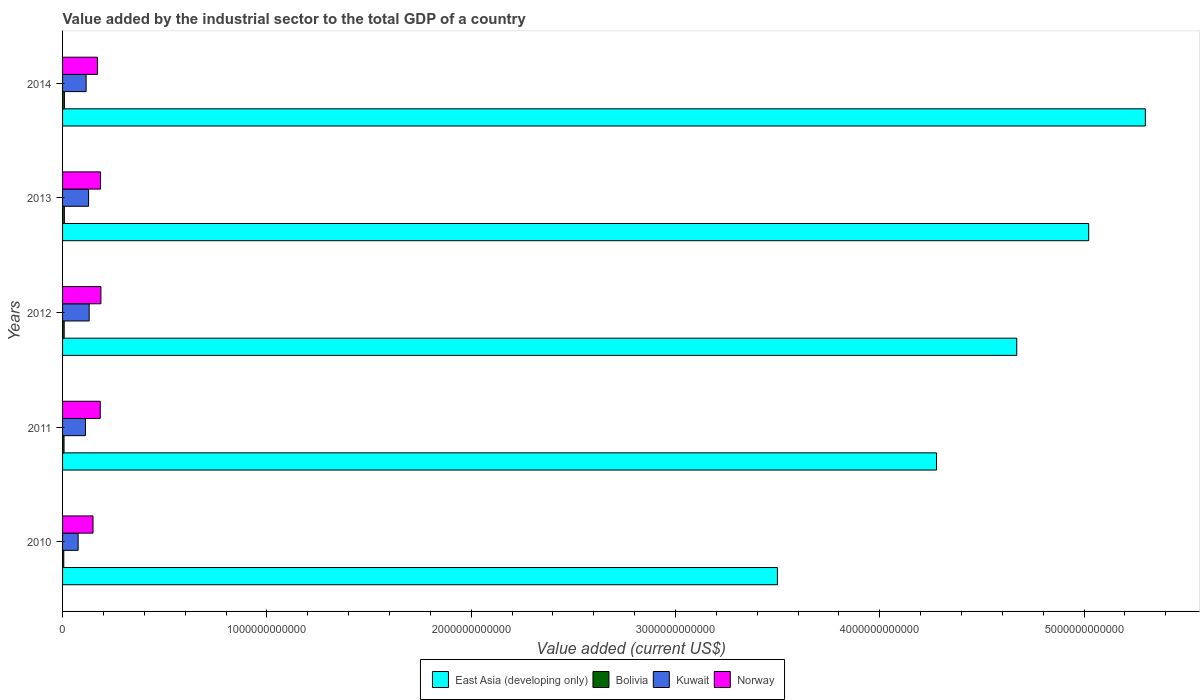How many different coloured bars are there?
Give a very brief answer. 4. How many groups of bars are there?
Make the answer very short. 5. Are the number of bars per tick equal to the number of legend labels?
Your answer should be very brief. Yes. Are the number of bars on each tick of the Y-axis equal?
Provide a short and direct response. Yes. How many bars are there on the 4th tick from the top?
Offer a very short reply. 4. How many bars are there on the 2nd tick from the bottom?
Your answer should be very brief. 4. What is the label of the 3rd group of bars from the top?
Offer a terse response. 2012. In how many cases, is the number of bars for a given year not equal to the number of legend labels?
Your response must be concise. 0. What is the value added by the industrial sector to the total GDP in Kuwait in 2013?
Your response must be concise. 1.27e+11. Across all years, what is the maximum value added by the industrial sector to the total GDP in Kuwait?
Make the answer very short. 1.30e+11. Across all years, what is the minimum value added by the industrial sector to the total GDP in Kuwait?
Your answer should be very brief. 7.63e+1. In which year was the value added by the industrial sector to the total GDP in East Asia (developing only) maximum?
Offer a very short reply. 2014. In which year was the value added by the industrial sector to the total GDP in Kuwait minimum?
Ensure brevity in your answer.  2010. What is the total value added by the industrial sector to the total GDP in Kuwait in the graph?
Provide a succinct answer. 5.61e+11. What is the difference between the value added by the industrial sector to the total GDP in Bolivia in 2011 and that in 2014?
Your answer should be very brief. -1.84e+09. What is the difference between the value added by the industrial sector to the total GDP in Norway in 2010 and the value added by the industrial sector to the total GDP in Bolivia in 2014?
Your response must be concise. 1.40e+11. What is the average value added by the industrial sector to the total GDP in East Asia (developing only) per year?
Make the answer very short. 4.55e+12. In the year 2010, what is the difference between the value added by the industrial sector to the total GDP in Norway and value added by the industrial sector to the total GDP in Bolivia?
Your response must be concise. 1.43e+11. What is the ratio of the value added by the industrial sector to the total GDP in Kuwait in 2011 to that in 2013?
Your answer should be compact. 0.88. Is the value added by the industrial sector to the total GDP in Bolivia in 2012 less than that in 2014?
Give a very brief answer. Yes. What is the difference between the highest and the second highest value added by the industrial sector to the total GDP in Kuwait?
Offer a terse response. 2.92e+09. What is the difference between the highest and the lowest value added by the industrial sector to the total GDP in Bolivia?
Ensure brevity in your answer.  3.19e+09. What does the 1st bar from the top in 2010 represents?
Your response must be concise. Norway. Is it the case that in every year, the sum of the value added by the industrial sector to the total GDP in Norway and value added by the industrial sector to the total GDP in East Asia (developing only) is greater than the value added by the industrial sector to the total GDP in Kuwait?
Keep it short and to the point. Yes. How many bars are there?
Provide a short and direct response. 20. Are all the bars in the graph horizontal?
Provide a succinct answer. Yes. How many years are there in the graph?
Your answer should be very brief. 5. What is the difference between two consecutive major ticks on the X-axis?
Give a very brief answer. 1.00e+12. Are the values on the major ticks of X-axis written in scientific E-notation?
Provide a short and direct response. No. Does the graph contain grids?
Provide a succinct answer. No. Where does the legend appear in the graph?
Offer a terse response. Bottom center. What is the title of the graph?
Your answer should be compact. Value added by the industrial sector to the total GDP of a country. What is the label or title of the X-axis?
Ensure brevity in your answer.  Value added (current US$). What is the Value added (current US$) in East Asia (developing only) in 2010?
Make the answer very short. 3.50e+12. What is the Value added (current US$) of Bolivia in 2010?
Your answer should be compact. 5.92e+09. What is the Value added (current US$) in Kuwait in 2010?
Offer a very short reply. 7.63e+1. What is the Value added (current US$) of Norway in 2010?
Give a very brief answer. 1.49e+11. What is the Value added (current US$) in East Asia (developing only) in 2011?
Provide a succinct answer. 4.28e+12. What is the Value added (current US$) in Bolivia in 2011?
Your answer should be very brief. 7.28e+09. What is the Value added (current US$) in Kuwait in 2011?
Your response must be concise. 1.12e+11. What is the Value added (current US$) of Norway in 2011?
Offer a terse response. 1.84e+11. What is the Value added (current US$) of East Asia (developing only) in 2012?
Offer a terse response. 4.67e+12. What is the Value added (current US$) in Bolivia in 2012?
Give a very brief answer. 7.95e+09. What is the Value added (current US$) of Kuwait in 2012?
Your answer should be compact. 1.30e+11. What is the Value added (current US$) in Norway in 2012?
Ensure brevity in your answer.  1.88e+11. What is the Value added (current US$) of East Asia (developing only) in 2013?
Give a very brief answer. 5.02e+12. What is the Value added (current US$) of Bolivia in 2013?
Your answer should be very brief. 8.74e+09. What is the Value added (current US$) of Kuwait in 2013?
Provide a succinct answer. 1.27e+11. What is the Value added (current US$) in Norway in 2013?
Provide a succinct answer. 1.86e+11. What is the Value added (current US$) of East Asia (developing only) in 2014?
Your answer should be compact. 5.30e+12. What is the Value added (current US$) in Bolivia in 2014?
Your answer should be very brief. 9.12e+09. What is the Value added (current US$) in Kuwait in 2014?
Keep it short and to the point. 1.15e+11. What is the Value added (current US$) of Norway in 2014?
Provide a succinct answer. 1.71e+11. Across all years, what is the maximum Value added (current US$) in East Asia (developing only)?
Your answer should be very brief. 5.30e+12. Across all years, what is the maximum Value added (current US$) of Bolivia?
Keep it short and to the point. 9.12e+09. Across all years, what is the maximum Value added (current US$) of Kuwait?
Provide a short and direct response. 1.30e+11. Across all years, what is the maximum Value added (current US$) of Norway?
Your answer should be compact. 1.88e+11. Across all years, what is the minimum Value added (current US$) in East Asia (developing only)?
Provide a succinct answer. 3.50e+12. Across all years, what is the minimum Value added (current US$) of Bolivia?
Make the answer very short. 5.92e+09. Across all years, what is the minimum Value added (current US$) in Kuwait?
Ensure brevity in your answer.  7.63e+1. Across all years, what is the minimum Value added (current US$) of Norway?
Give a very brief answer. 1.49e+11. What is the total Value added (current US$) in East Asia (developing only) in the graph?
Your response must be concise. 2.28e+13. What is the total Value added (current US$) in Bolivia in the graph?
Offer a terse response. 3.90e+1. What is the total Value added (current US$) of Kuwait in the graph?
Ensure brevity in your answer.  5.61e+11. What is the total Value added (current US$) of Norway in the graph?
Offer a very short reply. 8.78e+11. What is the difference between the Value added (current US$) of East Asia (developing only) in 2010 and that in 2011?
Your response must be concise. -7.79e+11. What is the difference between the Value added (current US$) of Bolivia in 2010 and that in 2011?
Keep it short and to the point. -1.35e+09. What is the difference between the Value added (current US$) in Kuwait in 2010 and that in 2011?
Keep it short and to the point. -3.58e+1. What is the difference between the Value added (current US$) of Norway in 2010 and that in 2011?
Make the answer very short. -3.54e+1. What is the difference between the Value added (current US$) of East Asia (developing only) in 2010 and that in 2012?
Ensure brevity in your answer.  -1.17e+12. What is the difference between the Value added (current US$) of Bolivia in 2010 and that in 2012?
Give a very brief answer. -2.02e+09. What is the difference between the Value added (current US$) in Kuwait in 2010 and that in 2012?
Your answer should be compact. -5.40e+1. What is the difference between the Value added (current US$) in Norway in 2010 and that in 2012?
Your answer should be compact. -3.86e+1. What is the difference between the Value added (current US$) in East Asia (developing only) in 2010 and that in 2013?
Keep it short and to the point. -1.52e+12. What is the difference between the Value added (current US$) of Bolivia in 2010 and that in 2013?
Offer a very short reply. -2.82e+09. What is the difference between the Value added (current US$) in Kuwait in 2010 and that in 2013?
Your answer should be compact. -5.11e+1. What is the difference between the Value added (current US$) of Norway in 2010 and that in 2013?
Provide a short and direct response. -3.69e+1. What is the difference between the Value added (current US$) in East Asia (developing only) in 2010 and that in 2014?
Keep it short and to the point. -1.80e+12. What is the difference between the Value added (current US$) of Bolivia in 2010 and that in 2014?
Give a very brief answer. -3.19e+09. What is the difference between the Value added (current US$) of Kuwait in 2010 and that in 2014?
Your answer should be very brief. -3.91e+1. What is the difference between the Value added (current US$) of Norway in 2010 and that in 2014?
Offer a very short reply. -2.18e+1. What is the difference between the Value added (current US$) in East Asia (developing only) in 2011 and that in 2012?
Offer a terse response. -3.93e+11. What is the difference between the Value added (current US$) of Bolivia in 2011 and that in 2012?
Give a very brief answer. -6.68e+08. What is the difference between the Value added (current US$) in Kuwait in 2011 and that in 2012?
Provide a short and direct response. -1.82e+1. What is the difference between the Value added (current US$) in Norway in 2011 and that in 2012?
Keep it short and to the point. -3.21e+09. What is the difference between the Value added (current US$) in East Asia (developing only) in 2011 and that in 2013?
Provide a short and direct response. -7.45e+11. What is the difference between the Value added (current US$) of Bolivia in 2011 and that in 2013?
Provide a short and direct response. -1.47e+09. What is the difference between the Value added (current US$) of Kuwait in 2011 and that in 2013?
Offer a very short reply. -1.53e+1. What is the difference between the Value added (current US$) of Norway in 2011 and that in 2013?
Provide a short and direct response. -1.47e+09. What is the difference between the Value added (current US$) of East Asia (developing only) in 2011 and that in 2014?
Your response must be concise. -1.02e+12. What is the difference between the Value added (current US$) of Bolivia in 2011 and that in 2014?
Your response must be concise. -1.84e+09. What is the difference between the Value added (current US$) in Kuwait in 2011 and that in 2014?
Ensure brevity in your answer.  -3.30e+09. What is the difference between the Value added (current US$) of Norway in 2011 and that in 2014?
Provide a succinct answer. 1.36e+1. What is the difference between the Value added (current US$) of East Asia (developing only) in 2012 and that in 2013?
Offer a terse response. -3.52e+11. What is the difference between the Value added (current US$) of Bolivia in 2012 and that in 2013?
Offer a very short reply. -7.98e+08. What is the difference between the Value added (current US$) in Kuwait in 2012 and that in 2013?
Provide a short and direct response. 2.92e+09. What is the difference between the Value added (current US$) of Norway in 2012 and that in 2013?
Give a very brief answer. 1.74e+09. What is the difference between the Value added (current US$) in East Asia (developing only) in 2012 and that in 2014?
Your response must be concise. -6.29e+11. What is the difference between the Value added (current US$) in Bolivia in 2012 and that in 2014?
Make the answer very short. -1.17e+09. What is the difference between the Value added (current US$) of Kuwait in 2012 and that in 2014?
Keep it short and to the point. 1.49e+1. What is the difference between the Value added (current US$) in Norway in 2012 and that in 2014?
Ensure brevity in your answer.  1.68e+1. What is the difference between the Value added (current US$) in East Asia (developing only) in 2013 and that in 2014?
Your response must be concise. -2.77e+11. What is the difference between the Value added (current US$) in Bolivia in 2013 and that in 2014?
Keep it short and to the point. -3.72e+08. What is the difference between the Value added (current US$) in Kuwait in 2013 and that in 2014?
Ensure brevity in your answer.  1.20e+1. What is the difference between the Value added (current US$) in Norway in 2013 and that in 2014?
Offer a very short reply. 1.51e+1. What is the difference between the Value added (current US$) of East Asia (developing only) in 2010 and the Value added (current US$) of Bolivia in 2011?
Your response must be concise. 3.49e+12. What is the difference between the Value added (current US$) of East Asia (developing only) in 2010 and the Value added (current US$) of Kuwait in 2011?
Your response must be concise. 3.39e+12. What is the difference between the Value added (current US$) of East Asia (developing only) in 2010 and the Value added (current US$) of Norway in 2011?
Give a very brief answer. 3.31e+12. What is the difference between the Value added (current US$) of Bolivia in 2010 and the Value added (current US$) of Kuwait in 2011?
Give a very brief answer. -1.06e+11. What is the difference between the Value added (current US$) in Bolivia in 2010 and the Value added (current US$) in Norway in 2011?
Offer a very short reply. -1.79e+11. What is the difference between the Value added (current US$) in Kuwait in 2010 and the Value added (current US$) in Norway in 2011?
Keep it short and to the point. -1.08e+11. What is the difference between the Value added (current US$) in East Asia (developing only) in 2010 and the Value added (current US$) in Bolivia in 2012?
Your response must be concise. 3.49e+12. What is the difference between the Value added (current US$) in East Asia (developing only) in 2010 and the Value added (current US$) in Kuwait in 2012?
Your response must be concise. 3.37e+12. What is the difference between the Value added (current US$) of East Asia (developing only) in 2010 and the Value added (current US$) of Norway in 2012?
Make the answer very short. 3.31e+12. What is the difference between the Value added (current US$) of Bolivia in 2010 and the Value added (current US$) of Kuwait in 2012?
Provide a succinct answer. -1.24e+11. What is the difference between the Value added (current US$) in Bolivia in 2010 and the Value added (current US$) in Norway in 2012?
Keep it short and to the point. -1.82e+11. What is the difference between the Value added (current US$) of Kuwait in 2010 and the Value added (current US$) of Norway in 2012?
Your answer should be very brief. -1.11e+11. What is the difference between the Value added (current US$) of East Asia (developing only) in 2010 and the Value added (current US$) of Bolivia in 2013?
Provide a succinct answer. 3.49e+12. What is the difference between the Value added (current US$) of East Asia (developing only) in 2010 and the Value added (current US$) of Kuwait in 2013?
Keep it short and to the point. 3.37e+12. What is the difference between the Value added (current US$) of East Asia (developing only) in 2010 and the Value added (current US$) of Norway in 2013?
Provide a short and direct response. 3.31e+12. What is the difference between the Value added (current US$) in Bolivia in 2010 and the Value added (current US$) in Kuwait in 2013?
Provide a succinct answer. -1.21e+11. What is the difference between the Value added (current US$) of Bolivia in 2010 and the Value added (current US$) of Norway in 2013?
Provide a succinct answer. -1.80e+11. What is the difference between the Value added (current US$) in Kuwait in 2010 and the Value added (current US$) in Norway in 2013?
Your answer should be compact. -1.10e+11. What is the difference between the Value added (current US$) of East Asia (developing only) in 2010 and the Value added (current US$) of Bolivia in 2014?
Provide a succinct answer. 3.49e+12. What is the difference between the Value added (current US$) of East Asia (developing only) in 2010 and the Value added (current US$) of Kuwait in 2014?
Your answer should be very brief. 3.38e+12. What is the difference between the Value added (current US$) of East Asia (developing only) in 2010 and the Value added (current US$) of Norway in 2014?
Offer a very short reply. 3.33e+12. What is the difference between the Value added (current US$) of Bolivia in 2010 and the Value added (current US$) of Kuwait in 2014?
Your answer should be very brief. -1.09e+11. What is the difference between the Value added (current US$) of Bolivia in 2010 and the Value added (current US$) of Norway in 2014?
Provide a short and direct response. -1.65e+11. What is the difference between the Value added (current US$) in Kuwait in 2010 and the Value added (current US$) in Norway in 2014?
Provide a succinct answer. -9.46e+1. What is the difference between the Value added (current US$) in East Asia (developing only) in 2011 and the Value added (current US$) in Bolivia in 2012?
Provide a short and direct response. 4.27e+12. What is the difference between the Value added (current US$) in East Asia (developing only) in 2011 and the Value added (current US$) in Kuwait in 2012?
Your answer should be compact. 4.15e+12. What is the difference between the Value added (current US$) of East Asia (developing only) in 2011 and the Value added (current US$) of Norway in 2012?
Offer a terse response. 4.09e+12. What is the difference between the Value added (current US$) in Bolivia in 2011 and the Value added (current US$) in Kuwait in 2012?
Give a very brief answer. -1.23e+11. What is the difference between the Value added (current US$) of Bolivia in 2011 and the Value added (current US$) of Norway in 2012?
Give a very brief answer. -1.80e+11. What is the difference between the Value added (current US$) in Kuwait in 2011 and the Value added (current US$) in Norway in 2012?
Offer a very short reply. -7.57e+1. What is the difference between the Value added (current US$) of East Asia (developing only) in 2011 and the Value added (current US$) of Bolivia in 2013?
Your answer should be very brief. 4.27e+12. What is the difference between the Value added (current US$) in East Asia (developing only) in 2011 and the Value added (current US$) in Kuwait in 2013?
Ensure brevity in your answer.  4.15e+12. What is the difference between the Value added (current US$) in East Asia (developing only) in 2011 and the Value added (current US$) in Norway in 2013?
Your answer should be compact. 4.09e+12. What is the difference between the Value added (current US$) in Bolivia in 2011 and the Value added (current US$) in Kuwait in 2013?
Offer a terse response. -1.20e+11. What is the difference between the Value added (current US$) in Bolivia in 2011 and the Value added (current US$) in Norway in 2013?
Provide a succinct answer. -1.79e+11. What is the difference between the Value added (current US$) in Kuwait in 2011 and the Value added (current US$) in Norway in 2013?
Offer a terse response. -7.40e+1. What is the difference between the Value added (current US$) of East Asia (developing only) in 2011 and the Value added (current US$) of Bolivia in 2014?
Your answer should be very brief. 4.27e+12. What is the difference between the Value added (current US$) in East Asia (developing only) in 2011 and the Value added (current US$) in Kuwait in 2014?
Offer a very short reply. 4.16e+12. What is the difference between the Value added (current US$) of East Asia (developing only) in 2011 and the Value added (current US$) of Norway in 2014?
Offer a very short reply. 4.11e+12. What is the difference between the Value added (current US$) in Bolivia in 2011 and the Value added (current US$) in Kuwait in 2014?
Your answer should be very brief. -1.08e+11. What is the difference between the Value added (current US$) of Bolivia in 2011 and the Value added (current US$) of Norway in 2014?
Make the answer very short. -1.64e+11. What is the difference between the Value added (current US$) of Kuwait in 2011 and the Value added (current US$) of Norway in 2014?
Ensure brevity in your answer.  -5.89e+1. What is the difference between the Value added (current US$) of East Asia (developing only) in 2012 and the Value added (current US$) of Bolivia in 2013?
Offer a very short reply. 4.66e+12. What is the difference between the Value added (current US$) in East Asia (developing only) in 2012 and the Value added (current US$) in Kuwait in 2013?
Offer a very short reply. 4.54e+12. What is the difference between the Value added (current US$) in East Asia (developing only) in 2012 and the Value added (current US$) in Norway in 2013?
Your response must be concise. 4.48e+12. What is the difference between the Value added (current US$) of Bolivia in 2012 and the Value added (current US$) of Kuwait in 2013?
Make the answer very short. -1.19e+11. What is the difference between the Value added (current US$) of Bolivia in 2012 and the Value added (current US$) of Norway in 2013?
Keep it short and to the point. -1.78e+11. What is the difference between the Value added (current US$) in Kuwait in 2012 and the Value added (current US$) in Norway in 2013?
Make the answer very short. -5.57e+1. What is the difference between the Value added (current US$) in East Asia (developing only) in 2012 and the Value added (current US$) in Bolivia in 2014?
Give a very brief answer. 4.66e+12. What is the difference between the Value added (current US$) in East Asia (developing only) in 2012 and the Value added (current US$) in Kuwait in 2014?
Your answer should be very brief. 4.56e+12. What is the difference between the Value added (current US$) in East Asia (developing only) in 2012 and the Value added (current US$) in Norway in 2014?
Your answer should be very brief. 4.50e+12. What is the difference between the Value added (current US$) in Bolivia in 2012 and the Value added (current US$) in Kuwait in 2014?
Offer a very short reply. -1.07e+11. What is the difference between the Value added (current US$) in Bolivia in 2012 and the Value added (current US$) in Norway in 2014?
Give a very brief answer. -1.63e+11. What is the difference between the Value added (current US$) in Kuwait in 2012 and the Value added (current US$) in Norway in 2014?
Your answer should be compact. -4.06e+1. What is the difference between the Value added (current US$) of East Asia (developing only) in 2013 and the Value added (current US$) of Bolivia in 2014?
Give a very brief answer. 5.01e+12. What is the difference between the Value added (current US$) of East Asia (developing only) in 2013 and the Value added (current US$) of Kuwait in 2014?
Your answer should be compact. 4.91e+12. What is the difference between the Value added (current US$) of East Asia (developing only) in 2013 and the Value added (current US$) of Norway in 2014?
Offer a terse response. 4.85e+12. What is the difference between the Value added (current US$) of Bolivia in 2013 and the Value added (current US$) of Kuwait in 2014?
Offer a very short reply. -1.07e+11. What is the difference between the Value added (current US$) in Bolivia in 2013 and the Value added (current US$) in Norway in 2014?
Your answer should be compact. -1.62e+11. What is the difference between the Value added (current US$) of Kuwait in 2013 and the Value added (current US$) of Norway in 2014?
Your response must be concise. -4.36e+1. What is the average Value added (current US$) of East Asia (developing only) per year?
Your answer should be very brief. 4.55e+12. What is the average Value added (current US$) of Bolivia per year?
Give a very brief answer. 7.80e+09. What is the average Value added (current US$) of Kuwait per year?
Offer a terse response. 1.12e+11. What is the average Value added (current US$) in Norway per year?
Your response must be concise. 1.76e+11. In the year 2010, what is the difference between the Value added (current US$) in East Asia (developing only) and Value added (current US$) in Bolivia?
Keep it short and to the point. 3.49e+12. In the year 2010, what is the difference between the Value added (current US$) of East Asia (developing only) and Value added (current US$) of Kuwait?
Ensure brevity in your answer.  3.42e+12. In the year 2010, what is the difference between the Value added (current US$) in East Asia (developing only) and Value added (current US$) in Norway?
Keep it short and to the point. 3.35e+12. In the year 2010, what is the difference between the Value added (current US$) in Bolivia and Value added (current US$) in Kuwait?
Give a very brief answer. -7.03e+1. In the year 2010, what is the difference between the Value added (current US$) of Bolivia and Value added (current US$) of Norway?
Your response must be concise. -1.43e+11. In the year 2010, what is the difference between the Value added (current US$) of Kuwait and Value added (current US$) of Norway?
Keep it short and to the point. -7.28e+1. In the year 2011, what is the difference between the Value added (current US$) in East Asia (developing only) and Value added (current US$) in Bolivia?
Ensure brevity in your answer.  4.27e+12. In the year 2011, what is the difference between the Value added (current US$) of East Asia (developing only) and Value added (current US$) of Kuwait?
Offer a very short reply. 4.17e+12. In the year 2011, what is the difference between the Value added (current US$) in East Asia (developing only) and Value added (current US$) in Norway?
Your response must be concise. 4.09e+12. In the year 2011, what is the difference between the Value added (current US$) of Bolivia and Value added (current US$) of Kuwait?
Provide a succinct answer. -1.05e+11. In the year 2011, what is the difference between the Value added (current US$) of Bolivia and Value added (current US$) of Norway?
Offer a terse response. -1.77e+11. In the year 2011, what is the difference between the Value added (current US$) of Kuwait and Value added (current US$) of Norway?
Ensure brevity in your answer.  -7.25e+1. In the year 2012, what is the difference between the Value added (current US$) of East Asia (developing only) and Value added (current US$) of Bolivia?
Ensure brevity in your answer.  4.66e+12. In the year 2012, what is the difference between the Value added (current US$) in East Asia (developing only) and Value added (current US$) in Kuwait?
Provide a short and direct response. 4.54e+12. In the year 2012, what is the difference between the Value added (current US$) in East Asia (developing only) and Value added (current US$) in Norway?
Provide a succinct answer. 4.48e+12. In the year 2012, what is the difference between the Value added (current US$) of Bolivia and Value added (current US$) of Kuwait?
Provide a short and direct response. -1.22e+11. In the year 2012, what is the difference between the Value added (current US$) of Bolivia and Value added (current US$) of Norway?
Offer a terse response. -1.80e+11. In the year 2012, what is the difference between the Value added (current US$) of Kuwait and Value added (current US$) of Norway?
Offer a very short reply. -5.75e+1. In the year 2013, what is the difference between the Value added (current US$) in East Asia (developing only) and Value added (current US$) in Bolivia?
Ensure brevity in your answer.  5.01e+12. In the year 2013, what is the difference between the Value added (current US$) in East Asia (developing only) and Value added (current US$) in Kuwait?
Your answer should be very brief. 4.90e+12. In the year 2013, what is the difference between the Value added (current US$) of East Asia (developing only) and Value added (current US$) of Norway?
Offer a terse response. 4.84e+12. In the year 2013, what is the difference between the Value added (current US$) of Bolivia and Value added (current US$) of Kuwait?
Your response must be concise. -1.19e+11. In the year 2013, what is the difference between the Value added (current US$) of Bolivia and Value added (current US$) of Norway?
Your answer should be compact. -1.77e+11. In the year 2013, what is the difference between the Value added (current US$) of Kuwait and Value added (current US$) of Norway?
Offer a very short reply. -5.87e+1. In the year 2014, what is the difference between the Value added (current US$) of East Asia (developing only) and Value added (current US$) of Bolivia?
Your answer should be compact. 5.29e+12. In the year 2014, what is the difference between the Value added (current US$) in East Asia (developing only) and Value added (current US$) in Kuwait?
Ensure brevity in your answer.  5.18e+12. In the year 2014, what is the difference between the Value added (current US$) in East Asia (developing only) and Value added (current US$) in Norway?
Your answer should be compact. 5.13e+12. In the year 2014, what is the difference between the Value added (current US$) of Bolivia and Value added (current US$) of Kuwait?
Provide a short and direct response. -1.06e+11. In the year 2014, what is the difference between the Value added (current US$) of Bolivia and Value added (current US$) of Norway?
Provide a short and direct response. -1.62e+11. In the year 2014, what is the difference between the Value added (current US$) in Kuwait and Value added (current US$) in Norway?
Your response must be concise. -5.56e+1. What is the ratio of the Value added (current US$) in East Asia (developing only) in 2010 to that in 2011?
Your response must be concise. 0.82. What is the ratio of the Value added (current US$) in Bolivia in 2010 to that in 2011?
Your response must be concise. 0.81. What is the ratio of the Value added (current US$) in Kuwait in 2010 to that in 2011?
Ensure brevity in your answer.  0.68. What is the ratio of the Value added (current US$) in Norway in 2010 to that in 2011?
Keep it short and to the point. 0.81. What is the ratio of the Value added (current US$) of East Asia (developing only) in 2010 to that in 2012?
Your answer should be very brief. 0.75. What is the ratio of the Value added (current US$) of Bolivia in 2010 to that in 2012?
Your response must be concise. 0.75. What is the ratio of the Value added (current US$) of Kuwait in 2010 to that in 2012?
Provide a short and direct response. 0.59. What is the ratio of the Value added (current US$) of Norway in 2010 to that in 2012?
Keep it short and to the point. 0.79. What is the ratio of the Value added (current US$) of East Asia (developing only) in 2010 to that in 2013?
Keep it short and to the point. 0.7. What is the ratio of the Value added (current US$) in Bolivia in 2010 to that in 2013?
Your answer should be very brief. 0.68. What is the ratio of the Value added (current US$) of Kuwait in 2010 to that in 2013?
Your answer should be very brief. 0.6. What is the ratio of the Value added (current US$) of Norway in 2010 to that in 2013?
Your answer should be very brief. 0.8. What is the ratio of the Value added (current US$) of East Asia (developing only) in 2010 to that in 2014?
Make the answer very short. 0.66. What is the ratio of the Value added (current US$) in Bolivia in 2010 to that in 2014?
Provide a short and direct response. 0.65. What is the ratio of the Value added (current US$) of Kuwait in 2010 to that in 2014?
Give a very brief answer. 0.66. What is the ratio of the Value added (current US$) in Norway in 2010 to that in 2014?
Ensure brevity in your answer.  0.87. What is the ratio of the Value added (current US$) of East Asia (developing only) in 2011 to that in 2012?
Provide a succinct answer. 0.92. What is the ratio of the Value added (current US$) of Bolivia in 2011 to that in 2012?
Offer a terse response. 0.92. What is the ratio of the Value added (current US$) in Kuwait in 2011 to that in 2012?
Keep it short and to the point. 0.86. What is the ratio of the Value added (current US$) in Norway in 2011 to that in 2012?
Your response must be concise. 0.98. What is the ratio of the Value added (current US$) of East Asia (developing only) in 2011 to that in 2013?
Provide a short and direct response. 0.85. What is the ratio of the Value added (current US$) of Bolivia in 2011 to that in 2013?
Your answer should be compact. 0.83. What is the ratio of the Value added (current US$) of Kuwait in 2011 to that in 2013?
Keep it short and to the point. 0.88. What is the ratio of the Value added (current US$) in East Asia (developing only) in 2011 to that in 2014?
Make the answer very short. 0.81. What is the ratio of the Value added (current US$) in Bolivia in 2011 to that in 2014?
Your answer should be compact. 0.8. What is the ratio of the Value added (current US$) in Kuwait in 2011 to that in 2014?
Give a very brief answer. 0.97. What is the ratio of the Value added (current US$) in Norway in 2011 to that in 2014?
Give a very brief answer. 1.08. What is the ratio of the Value added (current US$) in East Asia (developing only) in 2012 to that in 2013?
Offer a terse response. 0.93. What is the ratio of the Value added (current US$) in Bolivia in 2012 to that in 2013?
Make the answer very short. 0.91. What is the ratio of the Value added (current US$) of Kuwait in 2012 to that in 2013?
Make the answer very short. 1.02. What is the ratio of the Value added (current US$) in Norway in 2012 to that in 2013?
Your response must be concise. 1.01. What is the ratio of the Value added (current US$) in East Asia (developing only) in 2012 to that in 2014?
Make the answer very short. 0.88. What is the ratio of the Value added (current US$) of Bolivia in 2012 to that in 2014?
Your answer should be very brief. 0.87. What is the ratio of the Value added (current US$) in Kuwait in 2012 to that in 2014?
Offer a terse response. 1.13. What is the ratio of the Value added (current US$) of Norway in 2012 to that in 2014?
Provide a short and direct response. 1.1. What is the ratio of the Value added (current US$) of East Asia (developing only) in 2013 to that in 2014?
Give a very brief answer. 0.95. What is the ratio of the Value added (current US$) of Bolivia in 2013 to that in 2014?
Offer a terse response. 0.96. What is the ratio of the Value added (current US$) of Kuwait in 2013 to that in 2014?
Your response must be concise. 1.1. What is the ratio of the Value added (current US$) of Norway in 2013 to that in 2014?
Give a very brief answer. 1.09. What is the difference between the highest and the second highest Value added (current US$) in East Asia (developing only)?
Make the answer very short. 2.77e+11. What is the difference between the highest and the second highest Value added (current US$) in Bolivia?
Make the answer very short. 3.72e+08. What is the difference between the highest and the second highest Value added (current US$) of Kuwait?
Make the answer very short. 2.92e+09. What is the difference between the highest and the second highest Value added (current US$) in Norway?
Your answer should be compact. 1.74e+09. What is the difference between the highest and the lowest Value added (current US$) in East Asia (developing only)?
Provide a succinct answer. 1.80e+12. What is the difference between the highest and the lowest Value added (current US$) of Bolivia?
Your response must be concise. 3.19e+09. What is the difference between the highest and the lowest Value added (current US$) of Kuwait?
Provide a short and direct response. 5.40e+1. What is the difference between the highest and the lowest Value added (current US$) in Norway?
Keep it short and to the point. 3.86e+1. 